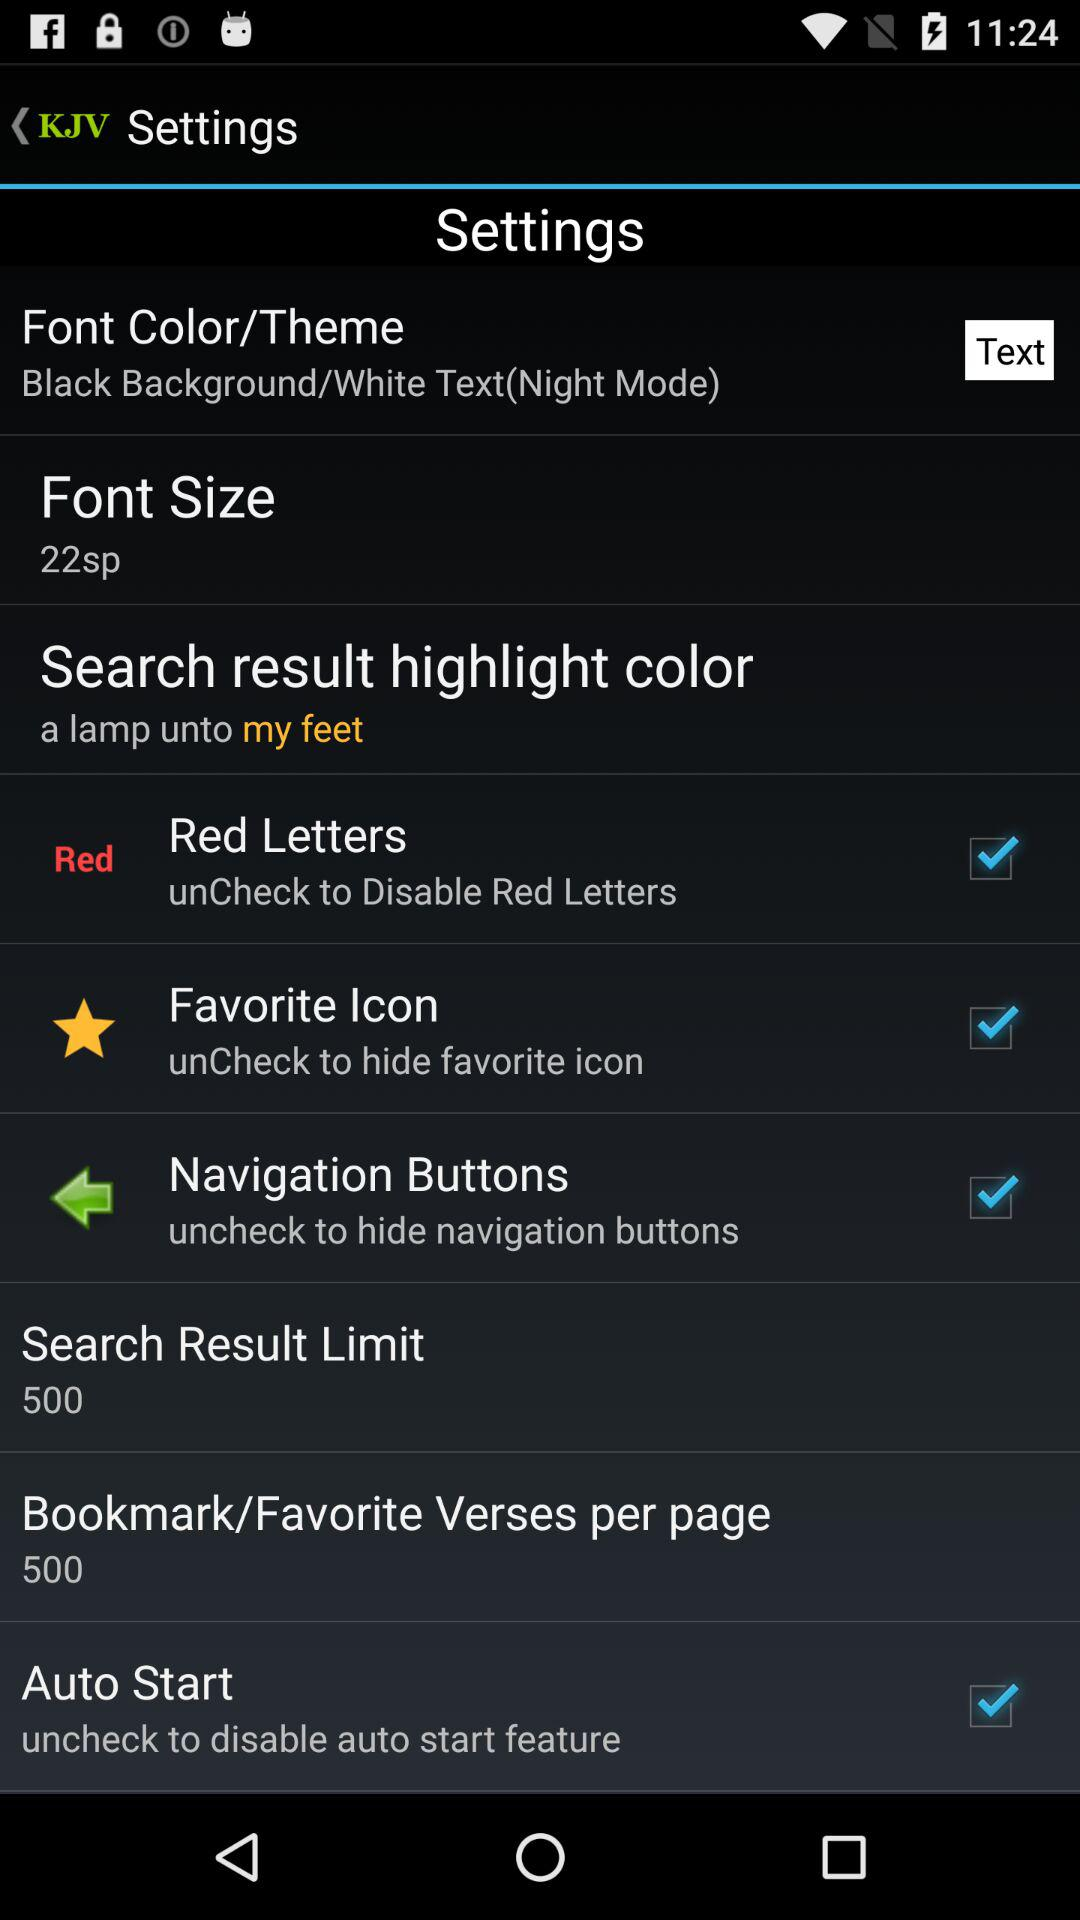What is the search result limit? The search result limit is 500. 